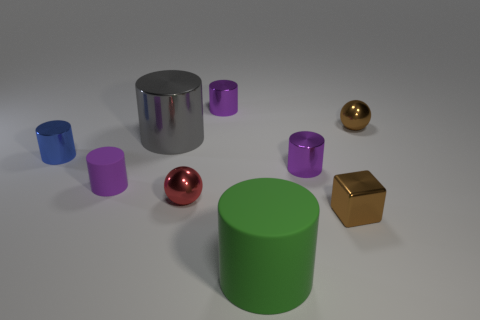Is the color of the small block the same as the big metal cylinder?
Offer a very short reply. No. Is the number of small purple metal objects less than the number of big red matte cylinders?
Your answer should be very brief. No. There is a tiny rubber object; are there any big gray cylinders in front of it?
Your response must be concise. No. Is the material of the tiny blue object the same as the cube?
Provide a short and direct response. Yes. There is a small rubber object that is the same shape as the big gray shiny object; what color is it?
Offer a terse response. Purple. Is the color of the ball that is in front of the tiny purple matte object the same as the tiny rubber object?
Make the answer very short. No. There is a small thing that is the same color as the block; what is its shape?
Give a very brief answer. Sphere. What number of big yellow cylinders have the same material as the blue cylinder?
Your answer should be very brief. 0. There is a blue cylinder; what number of purple objects are right of it?
Offer a terse response. 3. The brown shiny cube has what size?
Your response must be concise. Small. 